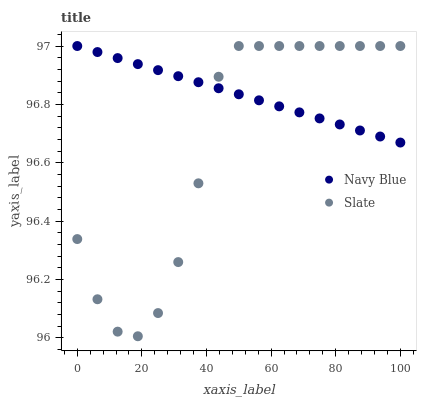Does Slate have the minimum area under the curve?
Answer yes or no. Yes. Does Navy Blue have the maximum area under the curve?
Answer yes or no. Yes. Does Slate have the maximum area under the curve?
Answer yes or no. No. Is Navy Blue the smoothest?
Answer yes or no. Yes. Is Slate the roughest?
Answer yes or no. Yes. Is Slate the smoothest?
Answer yes or no. No. Does Slate have the lowest value?
Answer yes or no. Yes. Does Slate have the highest value?
Answer yes or no. Yes. Does Slate intersect Navy Blue?
Answer yes or no. Yes. Is Slate less than Navy Blue?
Answer yes or no. No. Is Slate greater than Navy Blue?
Answer yes or no. No. 